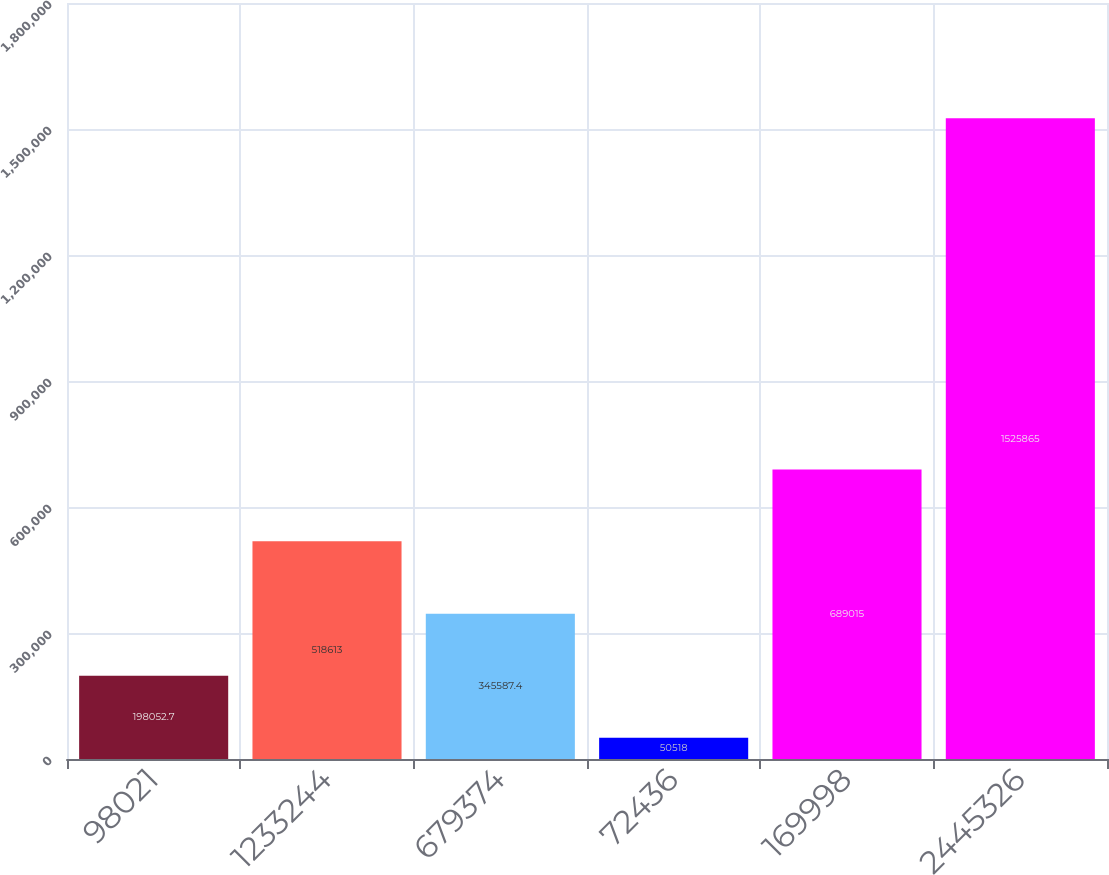Convert chart to OTSL. <chart><loc_0><loc_0><loc_500><loc_500><bar_chart><fcel>98021<fcel>1233244<fcel>679374<fcel>72436<fcel>169998<fcel>2445326<nl><fcel>198053<fcel>518613<fcel>345587<fcel>50518<fcel>689015<fcel>1.52586e+06<nl></chart> 